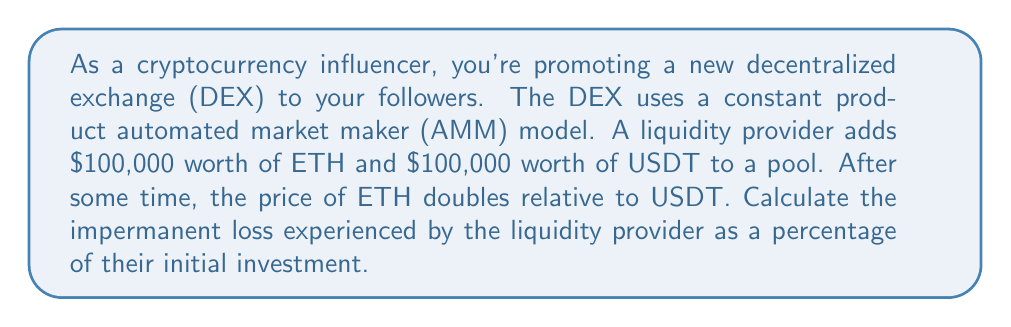Help me with this question. To calculate the impermanent loss, we'll follow these steps:

1) Let's define our variables:
   $x_0$ = initial ETH price (in USDT)
   $x_1$ = new ETH price (in USDT)
   $P$ = price ratio $= \frac{x_1}{x_0}$

2) The impermanent loss formula is:

   $$IL = 2 \sqrt{P} / (1+P) - 1$$

3) In this case, the price of ETH doubled, so $P = 2$

4) Let's plug this into our formula:

   $$IL = 2 \sqrt{2} / (1+2) - 1$$

5) Simplify:
   $$IL = 2 \sqrt{2} / 3 - 1$$
   $$IL = (2 \sqrt{2} - 3) / 3$$

6) Calculate the value:
   $$IL \approx -0.0557 \text{ or } -5.57\%$$

7) To express this as a percentage of the initial investment:
   $$\text{Percentage Loss} = 5.57\%$$

This means the liquidity provider has experienced an impermanent loss of approximately 5.57% of their initial investment due to the price change.
Answer: The impermanent loss experienced by the liquidity provider is approximately 5.57% of their initial investment. 